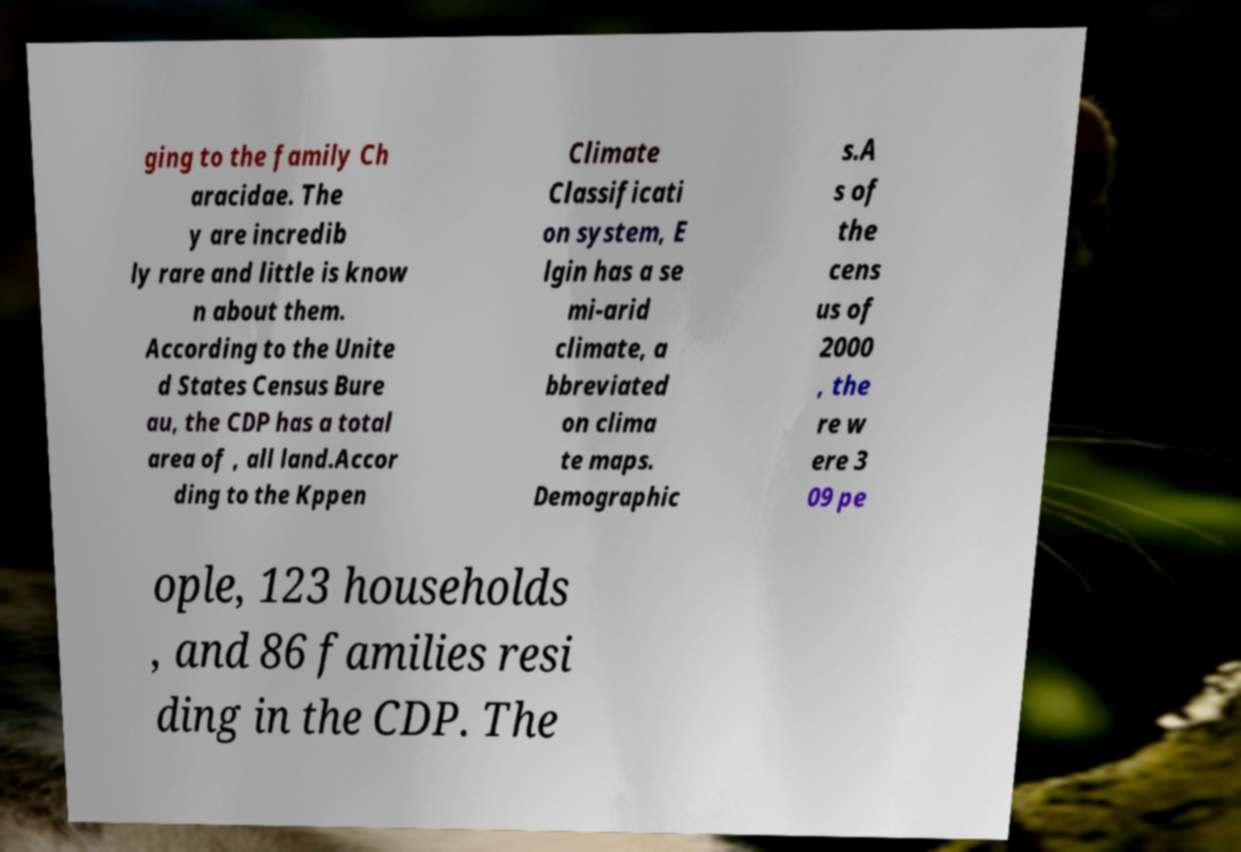What messages or text are displayed in this image? I need them in a readable, typed format. ging to the family Ch aracidae. The y are incredib ly rare and little is know n about them. According to the Unite d States Census Bure au, the CDP has a total area of , all land.Accor ding to the Kppen Climate Classificati on system, E lgin has a se mi-arid climate, a bbreviated on clima te maps. Demographic s.A s of the cens us of 2000 , the re w ere 3 09 pe ople, 123 households , and 86 families resi ding in the CDP. The 